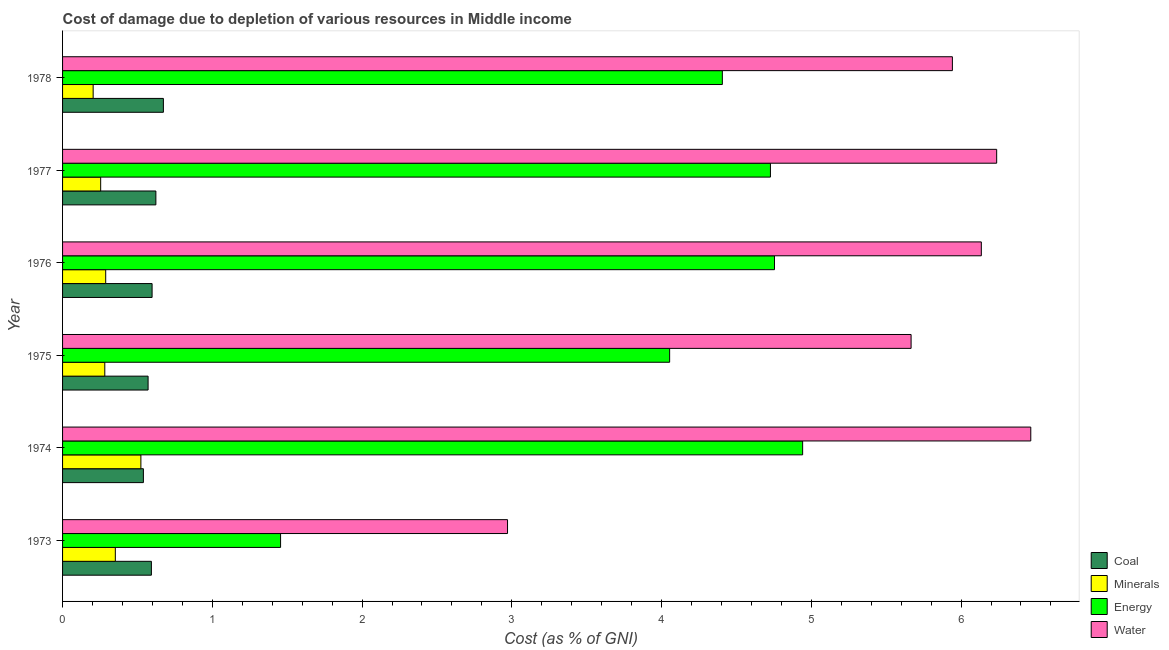How many different coloured bars are there?
Offer a very short reply. 4. Are the number of bars per tick equal to the number of legend labels?
Keep it short and to the point. Yes. Are the number of bars on each tick of the Y-axis equal?
Make the answer very short. Yes. How many bars are there on the 3rd tick from the bottom?
Make the answer very short. 4. What is the label of the 5th group of bars from the top?
Keep it short and to the point. 1974. What is the cost of damage due to depletion of energy in 1978?
Your answer should be compact. 4.41. Across all years, what is the maximum cost of damage due to depletion of minerals?
Your answer should be compact. 0.52. Across all years, what is the minimum cost of damage due to depletion of coal?
Provide a short and direct response. 0.54. In which year was the cost of damage due to depletion of coal maximum?
Keep it short and to the point. 1978. In which year was the cost of damage due to depletion of coal minimum?
Your answer should be compact. 1974. What is the total cost of damage due to depletion of water in the graph?
Your answer should be very brief. 33.42. What is the difference between the cost of damage due to depletion of minerals in 1976 and the cost of damage due to depletion of energy in 1977?
Your answer should be compact. -4.44. What is the average cost of damage due to depletion of water per year?
Offer a terse response. 5.57. In the year 1977, what is the difference between the cost of damage due to depletion of minerals and cost of damage due to depletion of coal?
Your response must be concise. -0.37. What is the ratio of the cost of damage due to depletion of minerals in 1973 to that in 1976?
Your response must be concise. 1.22. Is the cost of damage due to depletion of energy in 1976 less than that in 1978?
Your answer should be very brief. No. Is the difference between the cost of damage due to depletion of water in 1974 and 1976 greater than the difference between the cost of damage due to depletion of minerals in 1974 and 1976?
Your answer should be compact. Yes. What is the difference between the highest and the lowest cost of damage due to depletion of water?
Provide a short and direct response. 3.49. In how many years, is the cost of damage due to depletion of coal greater than the average cost of damage due to depletion of coal taken over all years?
Your response must be concise. 2. Is the sum of the cost of damage due to depletion of minerals in 1974 and 1977 greater than the maximum cost of damage due to depletion of water across all years?
Make the answer very short. No. Is it the case that in every year, the sum of the cost of damage due to depletion of energy and cost of damage due to depletion of water is greater than the sum of cost of damage due to depletion of coal and cost of damage due to depletion of minerals?
Ensure brevity in your answer.  Yes. What does the 3rd bar from the top in 1977 represents?
Provide a succinct answer. Minerals. What does the 4th bar from the bottom in 1974 represents?
Your response must be concise. Water. Is it the case that in every year, the sum of the cost of damage due to depletion of coal and cost of damage due to depletion of minerals is greater than the cost of damage due to depletion of energy?
Make the answer very short. No. Are all the bars in the graph horizontal?
Give a very brief answer. Yes. How many years are there in the graph?
Ensure brevity in your answer.  6. What is the difference between two consecutive major ticks on the X-axis?
Your answer should be very brief. 1. Does the graph contain any zero values?
Ensure brevity in your answer.  No. Does the graph contain grids?
Offer a terse response. No. How many legend labels are there?
Your response must be concise. 4. How are the legend labels stacked?
Give a very brief answer. Vertical. What is the title of the graph?
Offer a terse response. Cost of damage due to depletion of various resources in Middle income . Does "Fourth 20% of population" appear as one of the legend labels in the graph?
Your answer should be very brief. No. What is the label or title of the X-axis?
Provide a succinct answer. Cost (as % of GNI). What is the Cost (as % of GNI) of Coal in 1973?
Your response must be concise. 0.59. What is the Cost (as % of GNI) of Minerals in 1973?
Keep it short and to the point. 0.35. What is the Cost (as % of GNI) in Energy in 1973?
Your answer should be very brief. 1.46. What is the Cost (as % of GNI) of Water in 1973?
Provide a succinct answer. 2.97. What is the Cost (as % of GNI) in Coal in 1974?
Offer a very short reply. 0.54. What is the Cost (as % of GNI) of Minerals in 1974?
Your response must be concise. 0.52. What is the Cost (as % of GNI) of Energy in 1974?
Keep it short and to the point. 4.94. What is the Cost (as % of GNI) of Water in 1974?
Give a very brief answer. 6.47. What is the Cost (as % of GNI) in Coal in 1975?
Provide a succinct answer. 0.57. What is the Cost (as % of GNI) in Minerals in 1975?
Your answer should be compact. 0.28. What is the Cost (as % of GNI) of Energy in 1975?
Make the answer very short. 4.05. What is the Cost (as % of GNI) of Water in 1975?
Make the answer very short. 5.67. What is the Cost (as % of GNI) of Coal in 1976?
Give a very brief answer. 0.6. What is the Cost (as % of GNI) of Minerals in 1976?
Your response must be concise. 0.29. What is the Cost (as % of GNI) of Energy in 1976?
Your answer should be very brief. 4.75. What is the Cost (as % of GNI) in Water in 1976?
Your response must be concise. 6.14. What is the Cost (as % of GNI) of Coal in 1977?
Ensure brevity in your answer.  0.62. What is the Cost (as % of GNI) in Minerals in 1977?
Make the answer very short. 0.25. What is the Cost (as % of GNI) of Energy in 1977?
Ensure brevity in your answer.  4.73. What is the Cost (as % of GNI) of Water in 1977?
Provide a succinct answer. 6.24. What is the Cost (as % of GNI) of Coal in 1978?
Make the answer very short. 0.67. What is the Cost (as % of GNI) in Minerals in 1978?
Ensure brevity in your answer.  0.2. What is the Cost (as % of GNI) of Energy in 1978?
Provide a short and direct response. 4.41. What is the Cost (as % of GNI) in Water in 1978?
Your answer should be very brief. 5.94. Across all years, what is the maximum Cost (as % of GNI) in Coal?
Keep it short and to the point. 0.67. Across all years, what is the maximum Cost (as % of GNI) in Minerals?
Offer a terse response. 0.52. Across all years, what is the maximum Cost (as % of GNI) of Energy?
Ensure brevity in your answer.  4.94. Across all years, what is the maximum Cost (as % of GNI) of Water?
Provide a short and direct response. 6.47. Across all years, what is the minimum Cost (as % of GNI) of Coal?
Give a very brief answer. 0.54. Across all years, what is the minimum Cost (as % of GNI) of Minerals?
Keep it short and to the point. 0.2. Across all years, what is the minimum Cost (as % of GNI) of Energy?
Provide a short and direct response. 1.46. Across all years, what is the minimum Cost (as % of GNI) of Water?
Your answer should be compact. 2.97. What is the total Cost (as % of GNI) in Coal in the graph?
Provide a succinct answer. 3.6. What is the total Cost (as % of GNI) in Minerals in the graph?
Provide a succinct answer. 1.9. What is the total Cost (as % of GNI) in Energy in the graph?
Offer a terse response. 24.34. What is the total Cost (as % of GNI) of Water in the graph?
Your answer should be compact. 33.42. What is the difference between the Cost (as % of GNI) of Coal in 1973 and that in 1974?
Your answer should be very brief. 0.05. What is the difference between the Cost (as % of GNI) of Minerals in 1973 and that in 1974?
Provide a short and direct response. -0.17. What is the difference between the Cost (as % of GNI) of Energy in 1973 and that in 1974?
Your answer should be compact. -3.49. What is the difference between the Cost (as % of GNI) of Water in 1973 and that in 1974?
Your answer should be very brief. -3.49. What is the difference between the Cost (as % of GNI) in Coal in 1973 and that in 1975?
Make the answer very short. 0.02. What is the difference between the Cost (as % of GNI) in Minerals in 1973 and that in 1975?
Your answer should be compact. 0.07. What is the difference between the Cost (as % of GNI) of Energy in 1973 and that in 1975?
Your answer should be very brief. -2.6. What is the difference between the Cost (as % of GNI) in Water in 1973 and that in 1975?
Offer a terse response. -2.69. What is the difference between the Cost (as % of GNI) of Coal in 1973 and that in 1976?
Provide a succinct answer. -0. What is the difference between the Cost (as % of GNI) of Minerals in 1973 and that in 1976?
Offer a terse response. 0.06. What is the difference between the Cost (as % of GNI) in Energy in 1973 and that in 1976?
Provide a short and direct response. -3.3. What is the difference between the Cost (as % of GNI) of Water in 1973 and that in 1976?
Ensure brevity in your answer.  -3.16. What is the difference between the Cost (as % of GNI) of Coal in 1973 and that in 1977?
Your answer should be compact. -0.03. What is the difference between the Cost (as % of GNI) in Minerals in 1973 and that in 1977?
Provide a short and direct response. 0.1. What is the difference between the Cost (as % of GNI) of Energy in 1973 and that in 1977?
Your response must be concise. -3.27. What is the difference between the Cost (as % of GNI) of Water in 1973 and that in 1977?
Offer a terse response. -3.27. What is the difference between the Cost (as % of GNI) of Coal in 1973 and that in 1978?
Provide a succinct answer. -0.08. What is the difference between the Cost (as % of GNI) in Minerals in 1973 and that in 1978?
Make the answer very short. 0.15. What is the difference between the Cost (as % of GNI) in Energy in 1973 and that in 1978?
Provide a short and direct response. -2.95. What is the difference between the Cost (as % of GNI) in Water in 1973 and that in 1978?
Keep it short and to the point. -2.97. What is the difference between the Cost (as % of GNI) of Coal in 1974 and that in 1975?
Provide a succinct answer. -0.03. What is the difference between the Cost (as % of GNI) of Minerals in 1974 and that in 1975?
Make the answer very short. 0.24. What is the difference between the Cost (as % of GNI) of Energy in 1974 and that in 1975?
Make the answer very short. 0.89. What is the difference between the Cost (as % of GNI) of Water in 1974 and that in 1975?
Your answer should be very brief. 0.8. What is the difference between the Cost (as % of GNI) of Coal in 1974 and that in 1976?
Give a very brief answer. -0.06. What is the difference between the Cost (as % of GNI) of Minerals in 1974 and that in 1976?
Your answer should be very brief. 0.23. What is the difference between the Cost (as % of GNI) of Energy in 1974 and that in 1976?
Your answer should be compact. 0.19. What is the difference between the Cost (as % of GNI) in Water in 1974 and that in 1976?
Keep it short and to the point. 0.33. What is the difference between the Cost (as % of GNI) of Coal in 1974 and that in 1977?
Keep it short and to the point. -0.08. What is the difference between the Cost (as % of GNI) in Minerals in 1974 and that in 1977?
Offer a terse response. 0.27. What is the difference between the Cost (as % of GNI) of Energy in 1974 and that in 1977?
Ensure brevity in your answer.  0.22. What is the difference between the Cost (as % of GNI) in Water in 1974 and that in 1977?
Give a very brief answer. 0.23. What is the difference between the Cost (as % of GNI) of Coal in 1974 and that in 1978?
Your answer should be compact. -0.13. What is the difference between the Cost (as % of GNI) of Minerals in 1974 and that in 1978?
Make the answer very short. 0.32. What is the difference between the Cost (as % of GNI) of Energy in 1974 and that in 1978?
Offer a very short reply. 0.54. What is the difference between the Cost (as % of GNI) in Water in 1974 and that in 1978?
Give a very brief answer. 0.52. What is the difference between the Cost (as % of GNI) in Coal in 1975 and that in 1976?
Ensure brevity in your answer.  -0.03. What is the difference between the Cost (as % of GNI) of Minerals in 1975 and that in 1976?
Your answer should be compact. -0.01. What is the difference between the Cost (as % of GNI) in Energy in 1975 and that in 1976?
Offer a very short reply. -0.7. What is the difference between the Cost (as % of GNI) in Water in 1975 and that in 1976?
Provide a short and direct response. -0.47. What is the difference between the Cost (as % of GNI) in Coal in 1975 and that in 1977?
Offer a very short reply. -0.05. What is the difference between the Cost (as % of GNI) of Minerals in 1975 and that in 1977?
Your response must be concise. 0.03. What is the difference between the Cost (as % of GNI) of Energy in 1975 and that in 1977?
Offer a very short reply. -0.67. What is the difference between the Cost (as % of GNI) of Water in 1975 and that in 1977?
Offer a terse response. -0.57. What is the difference between the Cost (as % of GNI) of Coal in 1975 and that in 1978?
Ensure brevity in your answer.  -0.1. What is the difference between the Cost (as % of GNI) in Minerals in 1975 and that in 1978?
Your answer should be compact. 0.08. What is the difference between the Cost (as % of GNI) in Energy in 1975 and that in 1978?
Offer a very short reply. -0.35. What is the difference between the Cost (as % of GNI) in Water in 1975 and that in 1978?
Offer a terse response. -0.28. What is the difference between the Cost (as % of GNI) of Coal in 1976 and that in 1977?
Provide a succinct answer. -0.03. What is the difference between the Cost (as % of GNI) of Minerals in 1976 and that in 1977?
Offer a terse response. 0.03. What is the difference between the Cost (as % of GNI) in Energy in 1976 and that in 1977?
Offer a very short reply. 0.03. What is the difference between the Cost (as % of GNI) of Water in 1976 and that in 1977?
Make the answer very short. -0.1. What is the difference between the Cost (as % of GNI) in Coal in 1976 and that in 1978?
Your answer should be very brief. -0.08. What is the difference between the Cost (as % of GNI) of Minerals in 1976 and that in 1978?
Give a very brief answer. 0.08. What is the difference between the Cost (as % of GNI) in Energy in 1976 and that in 1978?
Your answer should be compact. 0.35. What is the difference between the Cost (as % of GNI) in Water in 1976 and that in 1978?
Make the answer very short. 0.19. What is the difference between the Cost (as % of GNI) of Coal in 1977 and that in 1978?
Your answer should be compact. -0.05. What is the difference between the Cost (as % of GNI) of Minerals in 1977 and that in 1978?
Your response must be concise. 0.05. What is the difference between the Cost (as % of GNI) of Energy in 1977 and that in 1978?
Give a very brief answer. 0.32. What is the difference between the Cost (as % of GNI) of Water in 1977 and that in 1978?
Keep it short and to the point. 0.3. What is the difference between the Cost (as % of GNI) in Coal in 1973 and the Cost (as % of GNI) in Minerals in 1974?
Your response must be concise. 0.07. What is the difference between the Cost (as % of GNI) in Coal in 1973 and the Cost (as % of GNI) in Energy in 1974?
Provide a short and direct response. -4.35. What is the difference between the Cost (as % of GNI) of Coal in 1973 and the Cost (as % of GNI) of Water in 1974?
Give a very brief answer. -5.87. What is the difference between the Cost (as % of GNI) of Minerals in 1973 and the Cost (as % of GNI) of Energy in 1974?
Offer a terse response. -4.59. What is the difference between the Cost (as % of GNI) of Minerals in 1973 and the Cost (as % of GNI) of Water in 1974?
Your answer should be very brief. -6.11. What is the difference between the Cost (as % of GNI) in Energy in 1973 and the Cost (as % of GNI) in Water in 1974?
Your response must be concise. -5.01. What is the difference between the Cost (as % of GNI) of Coal in 1973 and the Cost (as % of GNI) of Minerals in 1975?
Your answer should be compact. 0.31. What is the difference between the Cost (as % of GNI) in Coal in 1973 and the Cost (as % of GNI) in Energy in 1975?
Keep it short and to the point. -3.46. What is the difference between the Cost (as % of GNI) of Coal in 1973 and the Cost (as % of GNI) of Water in 1975?
Keep it short and to the point. -5.07. What is the difference between the Cost (as % of GNI) of Minerals in 1973 and the Cost (as % of GNI) of Energy in 1975?
Make the answer very short. -3.7. What is the difference between the Cost (as % of GNI) of Minerals in 1973 and the Cost (as % of GNI) of Water in 1975?
Your answer should be very brief. -5.31. What is the difference between the Cost (as % of GNI) in Energy in 1973 and the Cost (as % of GNI) in Water in 1975?
Your answer should be very brief. -4.21. What is the difference between the Cost (as % of GNI) of Coal in 1973 and the Cost (as % of GNI) of Minerals in 1976?
Offer a very short reply. 0.31. What is the difference between the Cost (as % of GNI) in Coal in 1973 and the Cost (as % of GNI) in Energy in 1976?
Keep it short and to the point. -4.16. What is the difference between the Cost (as % of GNI) in Coal in 1973 and the Cost (as % of GNI) in Water in 1976?
Offer a terse response. -5.54. What is the difference between the Cost (as % of GNI) in Minerals in 1973 and the Cost (as % of GNI) in Energy in 1976?
Your response must be concise. -4.4. What is the difference between the Cost (as % of GNI) of Minerals in 1973 and the Cost (as % of GNI) of Water in 1976?
Your response must be concise. -5.78. What is the difference between the Cost (as % of GNI) of Energy in 1973 and the Cost (as % of GNI) of Water in 1976?
Give a very brief answer. -4.68. What is the difference between the Cost (as % of GNI) in Coal in 1973 and the Cost (as % of GNI) in Minerals in 1977?
Offer a terse response. 0.34. What is the difference between the Cost (as % of GNI) in Coal in 1973 and the Cost (as % of GNI) in Energy in 1977?
Your answer should be very brief. -4.13. What is the difference between the Cost (as % of GNI) in Coal in 1973 and the Cost (as % of GNI) in Water in 1977?
Provide a succinct answer. -5.64. What is the difference between the Cost (as % of GNI) in Minerals in 1973 and the Cost (as % of GNI) in Energy in 1977?
Provide a short and direct response. -4.37. What is the difference between the Cost (as % of GNI) in Minerals in 1973 and the Cost (as % of GNI) in Water in 1977?
Make the answer very short. -5.89. What is the difference between the Cost (as % of GNI) of Energy in 1973 and the Cost (as % of GNI) of Water in 1977?
Keep it short and to the point. -4.78. What is the difference between the Cost (as % of GNI) in Coal in 1973 and the Cost (as % of GNI) in Minerals in 1978?
Give a very brief answer. 0.39. What is the difference between the Cost (as % of GNI) in Coal in 1973 and the Cost (as % of GNI) in Energy in 1978?
Provide a short and direct response. -3.81. What is the difference between the Cost (as % of GNI) in Coal in 1973 and the Cost (as % of GNI) in Water in 1978?
Your response must be concise. -5.35. What is the difference between the Cost (as % of GNI) in Minerals in 1973 and the Cost (as % of GNI) in Energy in 1978?
Keep it short and to the point. -4.05. What is the difference between the Cost (as % of GNI) in Minerals in 1973 and the Cost (as % of GNI) in Water in 1978?
Your answer should be very brief. -5.59. What is the difference between the Cost (as % of GNI) in Energy in 1973 and the Cost (as % of GNI) in Water in 1978?
Your response must be concise. -4.49. What is the difference between the Cost (as % of GNI) of Coal in 1974 and the Cost (as % of GNI) of Minerals in 1975?
Offer a terse response. 0.26. What is the difference between the Cost (as % of GNI) in Coal in 1974 and the Cost (as % of GNI) in Energy in 1975?
Ensure brevity in your answer.  -3.51. What is the difference between the Cost (as % of GNI) of Coal in 1974 and the Cost (as % of GNI) of Water in 1975?
Keep it short and to the point. -5.13. What is the difference between the Cost (as % of GNI) of Minerals in 1974 and the Cost (as % of GNI) of Energy in 1975?
Ensure brevity in your answer.  -3.53. What is the difference between the Cost (as % of GNI) in Minerals in 1974 and the Cost (as % of GNI) in Water in 1975?
Provide a succinct answer. -5.14. What is the difference between the Cost (as % of GNI) in Energy in 1974 and the Cost (as % of GNI) in Water in 1975?
Offer a very short reply. -0.72. What is the difference between the Cost (as % of GNI) in Coal in 1974 and the Cost (as % of GNI) in Minerals in 1976?
Provide a succinct answer. 0.25. What is the difference between the Cost (as % of GNI) in Coal in 1974 and the Cost (as % of GNI) in Energy in 1976?
Offer a very short reply. -4.21. What is the difference between the Cost (as % of GNI) in Coal in 1974 and the Cost (as % of GNI) in Water in 1976?
Give a very brief answer. -5.6. What is the difference between the Cost (as % of GNI) of Minerals in 1974 and the Cost (as % of GNI) of Energy in 1976?
Provide a succinct answer. -4.23. What is the difference between the Cost (as % of GNI) of Minerals in 1974 and the Cost (as % of GNI) of Water in 1976?
Ensure brevity in your answer.  -5.61. What is the difference between the Cost (as % of GNI) in Energy in 1974 and the Cost (as % of GNI) in Water in 1976?
Ensure brevity in your answer.  -1.19. What is the difference between the Cost (as % of GNI) in Coal in 1974 and the Cost (as % of GNI) in Minerals in 1977?
Offer a very short reply. 0.29. What is the difference between the Cost (as % of GNI) in Coal in 1974 and the Cost (as % of GNI) in Energy in 1977?
Provide a succinct answer. -4.19. What is the difference between the Cost (as % of GNI) in Coal in 1974 and the Cost (as % of GNI) in Water in 1977?
Make the answer very short. -5.7. What is the difference between the Cost (as % of GNI) in Minerals in 1974 and the Cost (as % of GNI) in Energy in 1977?
Offer a terse response. -4.2. What is the difference between the Cost (as % of GNI) in Minerals in 1974 and the Cost (as % of GNI) in Water in 1977?
Keep it short and to the point. -5.71. What is the difference between the Cost (as % of GNI) in Energy in 1974 and the Cost (as % of GNI) in Water in 1977?
Give a very brief answer. -1.3. What is the difference between the Cost (as % of GNI) in Coal in 1974 and the Cost (as % of GNI) in Minerals in 1978?
Provide a succinct answer. 0.34. What is the difference between the Cost (as % of GNI) of Coal in 1974 and the Cost (as % of GNI) of Energy in 1978?
Your answer should be compact. -3.87. What is the difference between the Cost (as % of GNI) of Coal in 1974 and the Cost (as % of GNI) of Water in 1978?
Give a very brief answer. -5.4. What is the difference between the Cost (as % of GNI) in Minerals in 1974 and the Cost (as % of GNI) in Energy in 1978?
Give a very brief answer. -3.88. What is the difference between the Cost (as % of GNI) in Minerals in 1974 and the Cost (as % of GNI) in Water in 1978?
Offer a terse response. -5.42. What is the difference between the Cost (as % of GNI) of Energy in 1974 and the Cost (as % of GNI) of Water in 1978?
Offer a very short reply. -1. What is the difference between the Cost (as % of GNI) in Coal in 1975 and the Cost (as % of GNI) in Minerals in 1976?
Your answer should be compact. 0.28. What is the difference between the Cost (as % of GNI) in Coal in 1975 and the Cost (as % of GNI) in Energy in 1976?
Your answer should be compact. -4.18. What is the difference between the Cost (as % of GNI) of Coal in 1975 and the Cost (as % of GNI) of Water in 1976?
Make the answer very short. -5.56. What is the difference between the Cost (as % of GNI) in Minerals in 1975 and the Cost (as % of GNI) in Energy in 1976?
Offer a terse response. -4.47. What is the difference between the Cost (as % of GNI) of Minerals in 1975 and the Cost (as % of GNI) of Water in 1976?
Ensure brevity in your answer.  -5.85. What is the difference between the Cost (as % of GNI) in Energy in 1975 and the Cost (as % of GNI) in Water in 1976?
Make the answer very short. -2.08. What is the difference between the Cost (as % of GNI) of Coal in 1975 and the Cost (as % of GNI) of Minerals in 1977?
Offer a very short reply. 0.32. What is the difference between the Cost (as % of GNI) of Coal in 1975 and the Cost (as % of GNI) of Energy in 1977?
Make the answer very short. -4.16. What is the difference between the Cost (as % of GNI) in Coal in 1975 and the Cost (as % of GNI) in Water in 1977?
Ensure brevity in your answer.  -5.67. What is the difference between the Cost (as % of GNI) in Minerals in 1975 and the Cost (as % of GNI) in Energy in 1977?
Make the answer very short. -4.45. What is the difference between the Cost (as % of GNI) of Minerals in 1975 and the Cost (as % of GNI) of Water in 1977?
Give a very brief answer. -5.96. What is the difference between the Cost (as % of GNI) in Energy in 1975 and the Cost (as % of GNI) in Water in 1977?
Provide a short and direct response. -2.18. What is the difference between the Cost (as % of GNI) in Coal in 1975 and the Cost (as % of GNI) in Minerals in 1978?
Give a very brief answer. 0.37. What is the difference between the Cost (as % of GNI) of Coal in 1975 and the Cost (as % of GNI) of Energy in 1978?
Give a very brief answer. -3.83. What is the difference between the Cost (as % of GNI) of Coal in 1975 and the Cost (as % of GNI) of Water in 1978?
Offer a terse response. -5.37. What is the difference between the Cost (as % of GNI) in Minerals in 1975 and the Cost (as % of GNI) in Energy in 1978?
Give a very brief answer. -4.12. What is the difference between the Cost (as % of GNI) of Minerals in 1975 and the Cost (as % of GNI) of Water in 1978?
Keep it short and to the point. -5.66. What is the difference between the Cost (as % of GNI) of Energy in 1975 and the Cost (as % of GNI) of Water in 1978?
Your answer should be very brief. -1.89. What is the difference between the Cost (as % of GNI) in Coal in 1976 and the Cost (as % of GNI) in Minerals in 1977?
Provide a succinct answer. 0.34. What is the difference between the Cost (as % of GNI) of Coal in 1976 and the Cost (as % of GNI) of Energy in 1977?
Make the answer very short. -4.13. What is the difference between the Cost (as % of GNI) in Coal in 1976 and the Cost (as % of GNI) in Water in 1977?
Keep it short and to the point. -5.64. What is the difference between the Cost (as % of GNI) in Minerals in 1976 and the Cost (as % of GNI) in Energy in 1977?
Give a very brief answer. -4.44. What is the difference between the Cost (as % of GNI) of Minerals in 1976 and the Cost (as % of GNI) of Water in 1977?
Keep it short and to the point. -5.95. What is the difference between the Cost (as % of GNI) in Energy in 1976 and the Cost (as % of GNI) in Water in 1977?
Make the answer very short. -1.48. What is the difference between the Cost (as % of GNI) of Coal in 1976 and the Cost (as % of GNI) of Minerals in 1978?
Keep it short and to the point. 0.39. What is the difference between the Cost (as % of GNI) of Coal in 1976 and the Cost (as % of GNI) of Energy in 1978?
Your answer should be very brief. -3.81. What is the difference between the Cost (as % of GNI) of Coal in 1976 and the Cost (as % of GNI) of Water in 1978?
Offer a very short reply. -5.34. What is the difference between the Cost (as % of GNI) in Minerals in 1976 and the Cost (as % of GNI) in Energy in 1978?
Your response must be concise. -4.12. What is the difference between the Cost (as % of GNI) of Minerals in 1976 and the Cost (as % of GNI) of Water in 1978?
Your response must be concise. -5.65. What is the difference between the Cost (as % of GNI) in Energy in 1976 and the Cost (as % of GNI) in Water in 1978?
Keep it short and to the point. -1.19. What is the difference between the Cost (as % of GNI) in Coal in 1977 and the Cost (as % of GNI) in Minerals in 1978?
Your answer should be very brief. 0.42. What is the difference between the Cost (as % of GNI) in Coal in 1977 and the Cost (as % of GNI) in Energy in 1978?
Make the answer very short. -3.78. What is the difference between the Cost (as % of GNI) of Coal in 1977 and the Cost (as % of GNI) of Water in 1978?
Give a very brief answer. -5.32. What is the difference between the Cost (as % of GNI) in Minerals in 1977 and the Cost (as % of GNI) in Energy in 1978?
Your response must be concise. -4.15. What is the difference between the Cost (as % of GNI) in Minerals in 1977 and the Cost (as % of GNI) in Water in 1978?
Keep it short and to the point. -5.69. What is the difference between the Cost (as % of GNI) of Energy in 1977 and the Cost (as % of GNI) of Water in 1978?
Your answer should be compact. -1.22. What is the average Cost (as % of GNI) of Coal per year?
Make the answer very short. 0.6. What is the average Cost (as % of GNI) in Minerals per year?
Give a very brief answer. 0.32. What is the average Cost (as % of GNI) in Energy per year?
Give a very brief answer. 4.06. What is the average Cost (as % of GNI) of Water per year?
Your answer should be very brief. 5.57. In the year 1973, what is the difference between the Cost (as % of GNI) in Coal and Cost (as % of GNI) in Minerals?
Ensure brevity in your answer.  0.24. In the year 1973, what is the difference between the Cost (as % of GNI) in Coal and Cost (as % of GNI) in Energy?
Make the answer very short. -0.86. In the year 1973, what is the difference between the Cost (as % of GNI) of Coal and Cost (as % of GNI) of Water?
Offer a terse response. -2.38. In the year 1973, what is the difference between the Cost (as % of GNI) in Minerals and Cost (as % of GNI) in Energy?
Make the answer very short. -1.1. In the year 1973, what is the difference between the Cost (as % of GNI) of Minerals and Cost (as % of GNI) of Water?
Ensure brevity in your answer.  -2.62. In the year 1973, what is the difference between the Cost (as % of GNI) of Energy and Cost (as % of GNI) of Water?
Offer a terse response. -1.52. In the year 1974, what is the difference between the Cost (as % of GNI) of Coal and Cost (as % of GNI) of Minerals?
Provide a short and direct response. 0.02. In the year 1974, what is the difference between the Cost (as % of GNI) of Coal and Cost (as % of GNI) of Energy?
Give a very brief answer. -4.4. In the year 1974, what is the difference between the Cost (as % of GNI) in Coal and Cost (as % of GNI) in Water?
Your response must be concise. -5.93. In the year 1974, what is the difference between the Cost (as % of GNI) in Minerals and Cost (as % of GNI) in Energy?
Make the answer very short. -4.42. In the year 1974, what is the difference between the Cost (as % of GNI) in Minerals and Cost (as % of GNI) in Water?
Provide a succinct answer. -5.94. In the year 1974, what is the difference between the Cost (as % of GNI) in Energy and Cost (as % of GNI) in Water?
Provide a succinct answer. -1.52. In the year 1975, what is the difference between the Cost (as % of GNI) of Coal and Cost (as % of GNI) of Minerals?
Give a very brief answer. 0.29. In the year 1975, what is the difference between the Cost (as % of GNI) in Coal and Cost (as % of GNI) in Energy?
Keep it short and to the point. -3.48. In the year 1975, what is the difference between the Cost (as % of GNI) of Coal and Cost (as % of GNI) of Water?
Offer a very short reply. -5.1. In the year 1975, what is the difference between the Cost (as % of GNI) of Minerals and Cost (as % of GNI) of Energy?
Provide a succinct answer. -3.77. In the year 1975, what is the difference between the Cost (as % of GNI) of Minerals and Cost (as % of GNI) of Water?
Provide a short and direct response. -5.38. In the year 1975, what is the difference between the Cost (as % of GNI) of Energy and Cost (as % of GNI) of Water?
Ensure brevity in your answer.  -1.61. In the year 1976, what is the difference between the Cost (as % of GNI) of Coal and Cost (as % of GNI) of Minerals?
Keep it short and to the point. 0.31. In the year 1976, what is the difference between the Cost (as % of GNI) in Coal and Cost (as % of GNI) in Energy?
Provide a succinct answer. -4.16. In the year 1976, what is the difference between the Cost (as % of GNI) of Coal and Cost (as % of GNI) of Water?
Provide a short and direct response. -5.54. In the year 1976, what is the difference between the Cost (as % of GNI) of Minerals and Cost (as % of GNI) of Energy?
Make the answer very short. -4.47. In the year 1976, what is the difference between the Cost (as % of GNI) in Minerals and Cost (as % of GNI) in Water?
Offer a very short reply. -5.85. In the year 1976, what is the difference between the Cost (as % of GNI) in Energy and Cost (as % of GNI) in Water?
Your answer should be compact. -1.38. In the year 1977, what is the difference between the Cost (as % of GNI) of Coal and Cost (as % of GNI) of Minerals?
Offer a very short reply. 0.37. In the year 1977, what is the difference between the Cost (as % of GNI) in Coal and Cost (as % of GNI) in Energy?
Ensure brevity in your answer.  -4.1. In the year 1977, what is the difference between the Cost (as % of GNI) of Coal and Cost (as % of GNI) of Water?
Your answer should be compact. -5.61. In the year 1977, what is the difference between the Cost (as % of GNI) of Minerals and Cost (as % of GNI) of Energy?
Keep it short and to the point. -4.47. In the year 1977, what is the difference between the Cost (as % of GNI) in Minerals and Cost (as % of GNI) in Water?
Give a very brief answer. -5.98. In the year 1977, what is the difference between the Cost (as % of GNI) in Energy and Cost (as % of GNI) in Water?
Your answer should be very brief. -1.51. In the year 1978, what is the difference between the Cost (as % of GNI) of Coal and Cost (as % of GNI) of Minerals?
Give a very brief answer. 0.47. In the year 1978, what is the difference between the Cost (as % of GNI) in Coal and Cost (as % of GNI) in Energy?
Make the answer very short. -3.73. In the year 1978, what is the difference between the Cost (as % of GNI) in Coal and Cost (as % of GNI) in Water?
Ensure brevity in your answer.  -5.27. In the year 1978, what is the difference between the Cost (as % of GNI) of Minerals and Cost (as % of GNI) of Energy?
Give a very brief answer. -4.2. In the year 1978, what is the difference between the Cost (as % of GNI) in Minerals and Cost (as % of GNI) in Water?
Provide a succinct answer. -5.74. In the year 1978, what is the difference between the Cost (as % of GNI) of Energy and Cost (as % of GNI) of Water?
Offer a very short reply. -1.54. What is the ratio of the Cost (as % of GNI) of Coal in 1973 to that in 1974?
Your response must be concise. 1.1. What is the ratio of the Cost (as % of GNI) of Minerals in 1973 to that in 1974?
Provide a short and direct response. 0.67. What is the ratio of the Cost (as % of GNI) of Energy in 1973 to that in 1974?
Keep it short and to the point. 0.29. What is the ratio of the Cost (as % of GNI) of Water in 1973 to that in 1974?
Give a very brief answer. 0.46. What is the ratio of the Cost (as % of GNI) in Coal in 1973 to that in 1975?
Ensure brevity in your answer.  1.04. What is the ratio of the Cost (as % of GNI) of Minerals in 1973 to that in 1975?
Your answer should be compact. 1.25. What is the ratio of the Cost (as % of GNI) in Energy in 1973 to that in 1975?
Your response must be concise. 0.36. What is the ratio of the Cost (as % of GNI) in Water in 1973 to that in 1975?
Make the answer very short. 0.52. What is the ratio of the Cost (as % of GNI) in Coal in 1973 to that in 1976?
Your answer should be very brief. 0.99. What is the ratio of the Cost (as % of GNI) of Minerals in 1973 to that in 1976?
Keep it short and to the point. 1.22. What is the ratio of the Cost (as % of GNI) in Energy in 1973 to that in 1976?
Your response must be concise. 0.31. What is the ratio of the Cost (as % of GNI) in Water in 1973 to that in 1976?
Your answer should be very brief. 0.48. What is the ratio of the Cost (as % of GNI) in Coal in 1973 to that in 1977?
Your response must be concise. 0.95. What is the ratio of the Cost (as % of GNI) of Minerals in 1973 to that in 1977?
Your response must be concise. 1.38. What is the ratio of the Cost (as % of GNI) of Energy in 1973 to that in 1977?
Your answer should be very brief. 0.31. What is the ratio of the Cost (as % of GNI) of Water in 1973 to that in 1977?
Provide a short and direct response. 0.48. What is the ratio of the Cost (as % of GNI) in Coal in 1973 to that in 1978?
Ensure brevity in your answer.  0.88. What is the ratio of the Cost (as % of GNI) in Minerals in 1973 to that in 1978?
Provide a short and direct response. 1.72. What is the ratio of the Cost (as % of GNI) in Energy in 1973 to that in 1978?
Your answer should be compact. 0.33. What is the ratio of the Cost (as % of GNI) of Water in 1973 to that in 1978?
Ensure brevity in your answer.  0.5. What is the ratio of the Cost (as % of GNI) in Coal in 1974 to that in 1975?
Keep it short and to the point. 0.94. What is the ratio of the Cost (as % of GNI) of Minerals in 1974 to that in 1975?
Provide a short and direct response. 1.85. What is the ratio of the Cost (as % of GNI) of Energy in 1974 to that in 1975?
Provide a succinct answer. 1.22. What is the ratio of the Cost (as % of GNI) in Water in 1974 to that in 1975?
Provide a succinct answer. 1.14. What is the ratio of the Cost (as % of GNI) of Coal in 1974 to that in 1976?
Offer a terse response. 0.9. What is the ratio of the Cost (as % of GNI) of Minerals in 1974 to that in 1976?
Give a very brief answer. 1.82. What is the ratio of the Cost (as % of GNI) of Energy in 1974 to that in 1976?
Give a very brief answer. 1.04. What is the ratio of the Cost (as % of GNI) in Water in 1974 to that in 1976?
Provide a short and direct response. 1.05. What is the ratio of the Cost (as % of GNI) of Coal in 1974 to that in 1977?
Ensure brevity in your answer.  0.87. What is the ratio of the Cost (as % of GNI) of Minerals in 1974 to that in 1977?
Provide a short and direct response. 2.06. What is the ratio of the Cost (as % of GNI) in Energy in 1974 to that in 1977?
Keep it short and to the point. 1.05. What is the ratio of the Cost (as % of GNI) in Water in 1974 to that in 1977?
Provide a short and direct response. 1.04. What is the ratio of the Cost (as % of GNI) in Coal in 1974 to that in 1978?
Keep it short and to the point. 0.8. What is the ratio of the Cost (as % of GNI) in Minerals in 1974 to that in 1978?
Your answer should be very brief. 2.56. What is the ratio of the Cost (as % of GNI) in Energy in 1974 to that in 1978?
Ensure brevity in your answer.  1.12. What is the ratio of the Cost (as % of GNI) of Water in 1974 to that in 1978?
Your answer should be very brief. 1.09. What is the ratio of the Cost (as % of GNI) of Coal in 1975 to that in 1976?
Ensure brevity in your answer.  0.96. What is the ratio of the Cost (as % of GNI) of Minerals in 1975 to that in 1976?
Ensure brevity in your answer.  0.98. What is the ratio of the Cost (as % of GNI) of Energy in 1975 to that in 1976?
Provide a succinct answer. 0.85. What is the ratio of the Cost (as % of GNI) in Water in 1975 to that in 1976?
Your answer should be very brief. 0.92. What is the ratio of the Cost (as % of GNI) of Coal in 1975 to that in 1977?
Provide a short and direct response. 0.92. What is the ratio of the Cost (as % of GNI) in Minerals in 1975 to that in 1977?
Your response must be concise. 1.11. What is the ratio of the Cost (as % of GNI) in Energy in 1975 to that in 1977?
Your answer should be compact. 0.86. What is the ratio of the Cost (as % of GNI) of Water in 1975 to that in 1977?
Provide a short and direct response. 0.91. What is the ratio of the Cost (as % of GNI) in Coal in 1975 to that in 1978?
Make the answer very short. 0.85. What is the ratio of the Cost (as % of GNI) in Minerals in 1975 to that in 1978?
Offer a terse response. 1.38. What is the ratio of the Cost (as % of GNI) in Energy in 1975 to that in 1978?
Your answer should be compact. 0.92. What is the ratio of the Cost (as % of GNI) in Water in 1975 to that in 1978?
Your response must be concise. 0.95. What is the ratio of the Cost (as % of GNI) in Coal in 1976 to that in 1977?
Ensure brevity in your answer.  0.96. What is the ratio of the Cost (as % of GNI) in Minerals in 1976 to that in 1977?
Make the answer very short. 1.13. What is the ratio of the Cost (as % of GNI) in Energy in 1976 to that in 1977?
Keep it short and to the point. 1.01. What is the ratio of the Cost (as % of GNI) in Water in 1976 to that in 1977?
Your answer should be compact. 0.98. What is the ratio of the Cost (as % of GNI) of Coal in 1976 to that in 1978?
Your response must be concise. 0.89. What is the ratio of the Cost (as % of GNI) in Minerals in 1976 to that in 1978?
Offer a terse response. 1.41. What is the ratio of the Cost (as % of GNI) in Energy in 1976 to that in 1978?
Keep it short and to the point. 1.08. What is the ratio of the Cost (as % of GNI) in Water in 1976 to that in 1978?
Provide a short and direct response. 1.03. What is the ratio of the Cost (as % of GNI) of Coal in 1977 to that in 1978?
Your answer should be very brief. 0.93. What is the ratio of the Cost (as % of GNI) of Minerals in 1977 to that in 1978?
Offer a very short reply. 1.25. What is the ratio of the Cost (as % of GNI) in Energy in 1977 to that in 1978?
Provide a short and direct response. 1.07. What is the ratio of the Cost (as % of GNI) in Water in 1977 to that in 1978?
Offer a very short reply. 1.05. What is the difference between the highest and the second highest Cost (as % of GNI) of Coal?
Your answer should be compact. 0.05. What is the difference between the highest and the second highest Cost (as % of GNI) of Minerals?
Give a very brief answer. 0.17. What is the difference between the highest and the second highest Cost (as % of GNI) in Energy?
Make the answer very short. 0.19. What is the difference between the highest and the second highest Cost (as % of GNI) in Water?
Provide a succinct answer. 0.23. What is the difference between the highest and the lowest Cost (as % of GNI) in Coal?
Offer a very short reply. 0.13. What is the difference between the highest and the lowest Cost (as % of GNI) of Minerals?
Make the answer very short. 0.32. What is the difference between the highest and the lowest Cost (as % of GNI) of Energy?
Give a very brief answer. 3.49. What is the difference between the highest and the lowest Cost (as % of GNI) of Water?
Give a very brief answer. 3.49. 